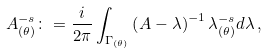<formula> <loc_0><loc_0><loc_500><loc_500>A _ { ( \theta ) } ^ { - s } \colon = { \frac { i } { 2 \pi } } \int _ { \Gamma _ { ( \theta ) } } \left ( A - \lambda \right ) ^ { - 1 } \lambda _ { ( \theta ) } ^ { - s } d \lambda \, ,</formula> 